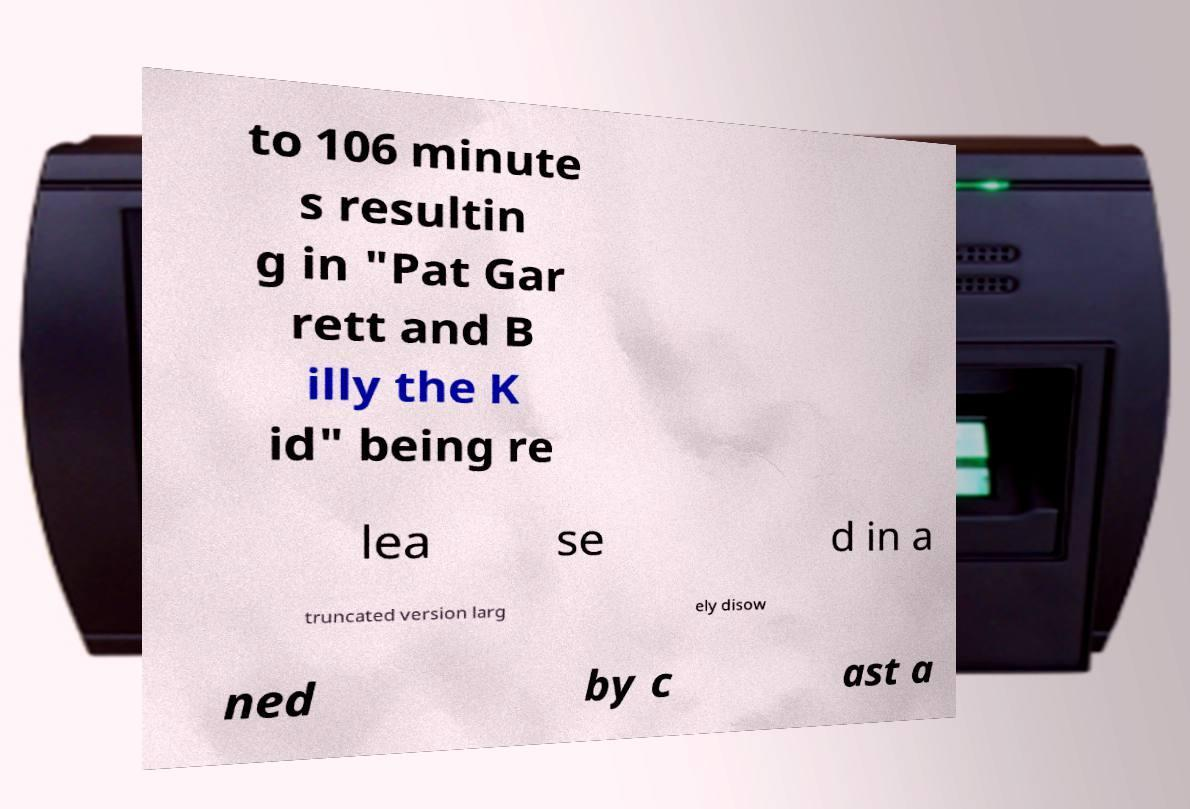There's text embedded in this image that I need extracted. Can you transcribe it verbatim? to 106 minute s resultin g in "Pat Gar rett and B illy the K id" being re lea se d in a truncated version larg ely disow ned by c ast a 